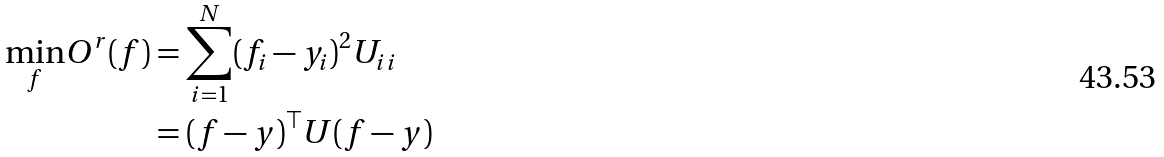<formula> <loc_0><loc_0><loc_500><loc_500>\underset { f } { \min } O ^ { r } ( f ) & = \sum _ { i = 1 } ^ { N } ( f _ { i } - y _ { i } ) ^ { 2 } U _ { i i } \\ & = ( f - y ) ^ { \top } U ( f - y )</formula> 